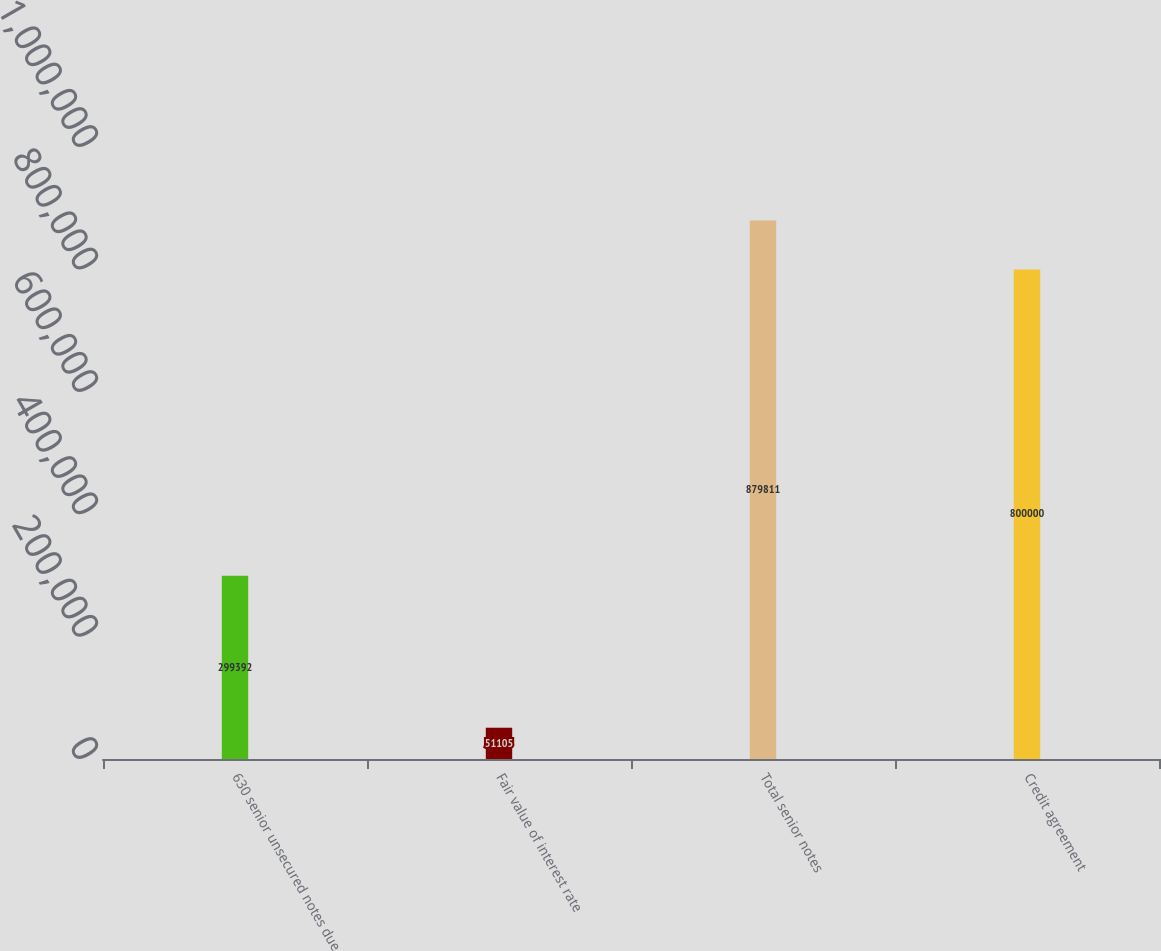Convert chart. <chart><loc_0><loc_0><loc_500><loc_500><bar_chart><fcel>630 senior unsecured notes due<fcel>Fair value of interest rate<fcel>Total senior notes<fcel>Credit agreement<nl><fcel>299392<fcel>51105<fcel>879811<fcel>800000<nl></chart> 